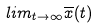<formula> <loc_0><loc_0><loc_500><loc_500>l i m _ { t \rightarrow \infty } \overline { x } ( t )</formula> 